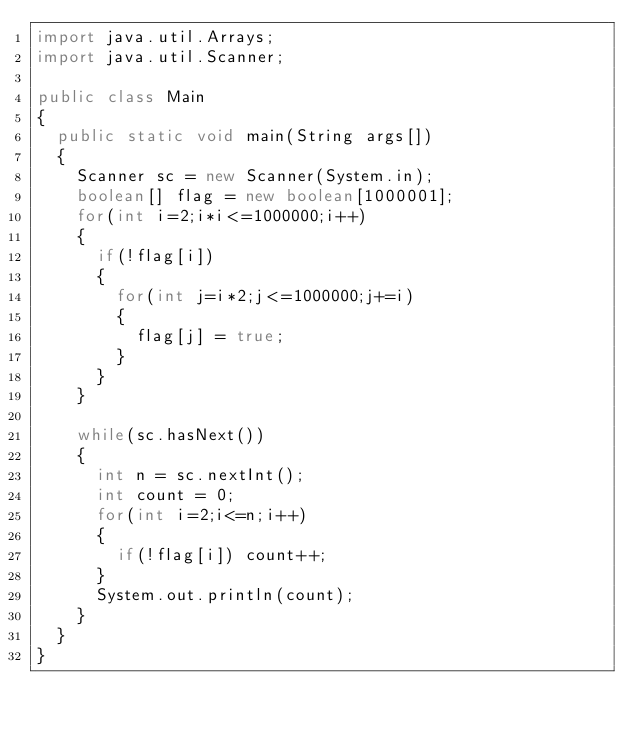Convert code to text. <code><loc_0><loc_0><loc_500><loc_500><_Java_>import java.util.Arrays;
import java.util.Scanner;

public class Main
{
	public static void main(String args[])
	{
		Scanner sc = new Scanner(System.in);
		boolean[] flag = new boolean[1000001];
		for(int i=2;i*i<=1000000;i++)
		{
			if(!flag[i])
			{
				for(int j=i*2;j<=1000000;j+=i)
				{
					flag[j] = true;
				}
			}
		}
		
		while(sc.hasNext())
		{
			int n = sc.nextInt();
			int count = 0;
			for(int i=2;i<=n;i++)
			{
				if(!flag[i]) count++;
			}
			System.out.println(count);
		}
	}
}</code> 